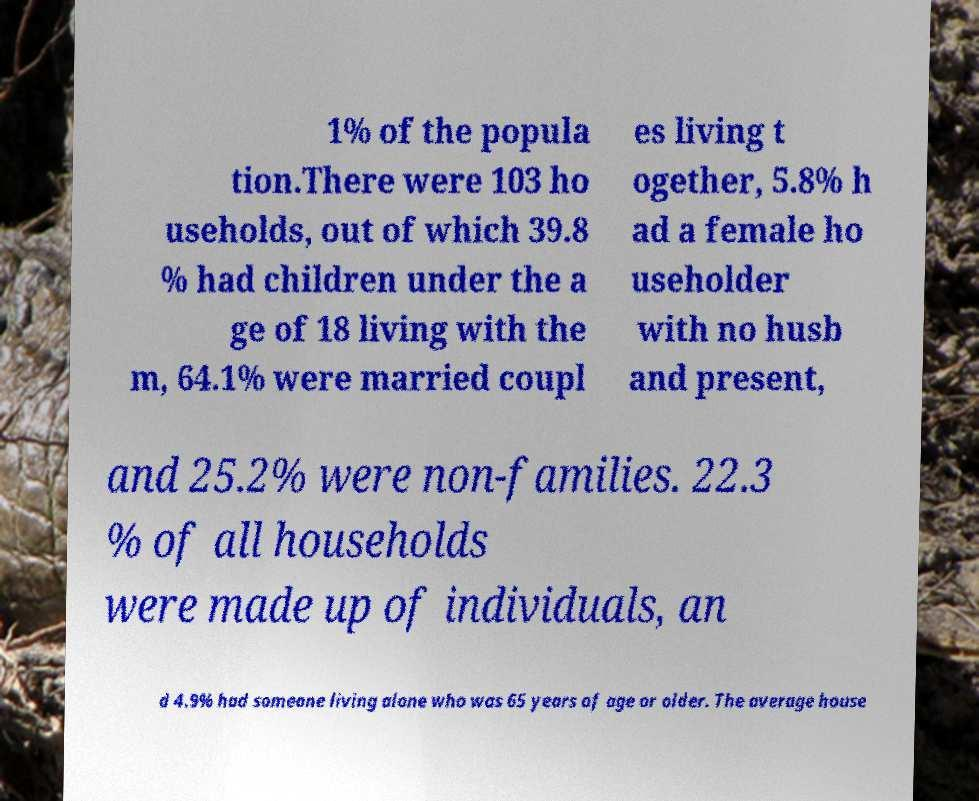Can you read and provide the text displayed in the image?This photo seems to have some interesting text. Can you extract and type it out for me? 1% of the popula tion.There were 103 ho useholds, out of which 39.8 % had children under the a ge of 18 living with the m, 64.1% were married coupl es living t ogether, 5.8% h ad a female ho useholder with no husb and present, and 25.2% were non-families. 22.3 % of all households were made up of individuals, an d 4.9% had someone living alone who was 65 years of age or older. The average house 